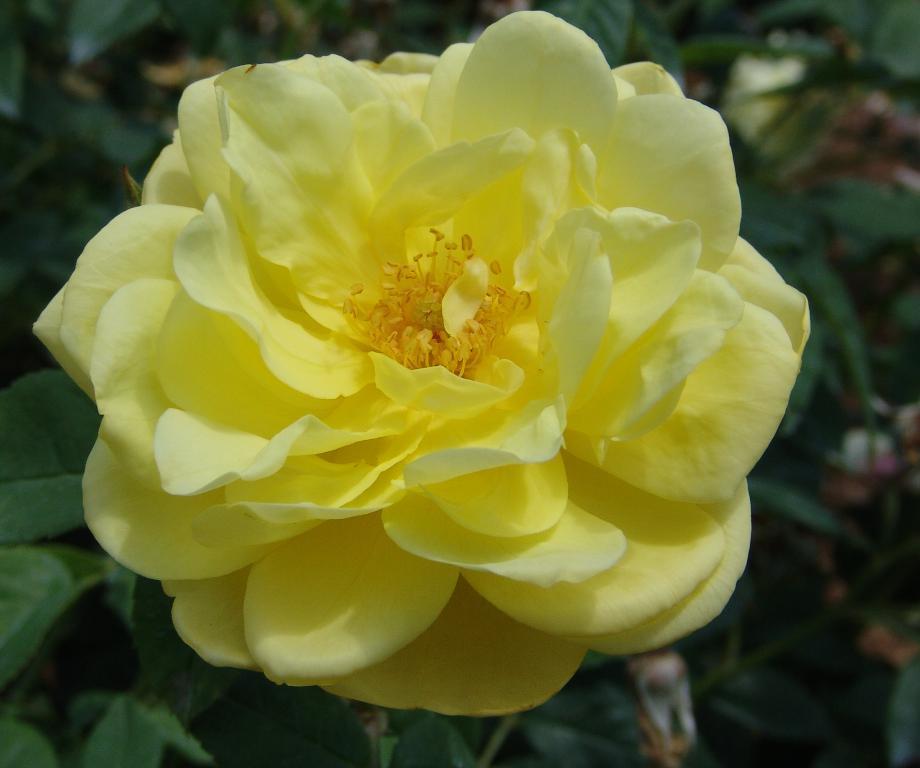How would you summarize this image in a sentence or two? There is a plant having a yellow color rose. In the background, there are other plants which are having green color leaves. 